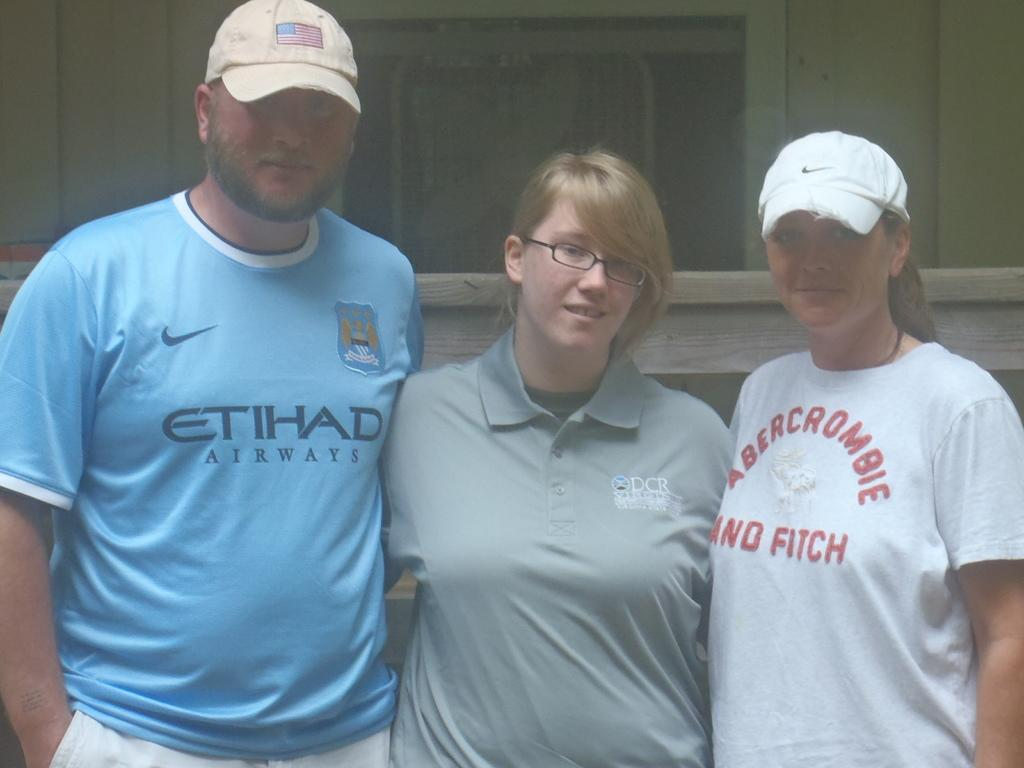<image>
Provide a brief description of the given image. A man in a Etihad Airways shirt poses with two women for a photo. 